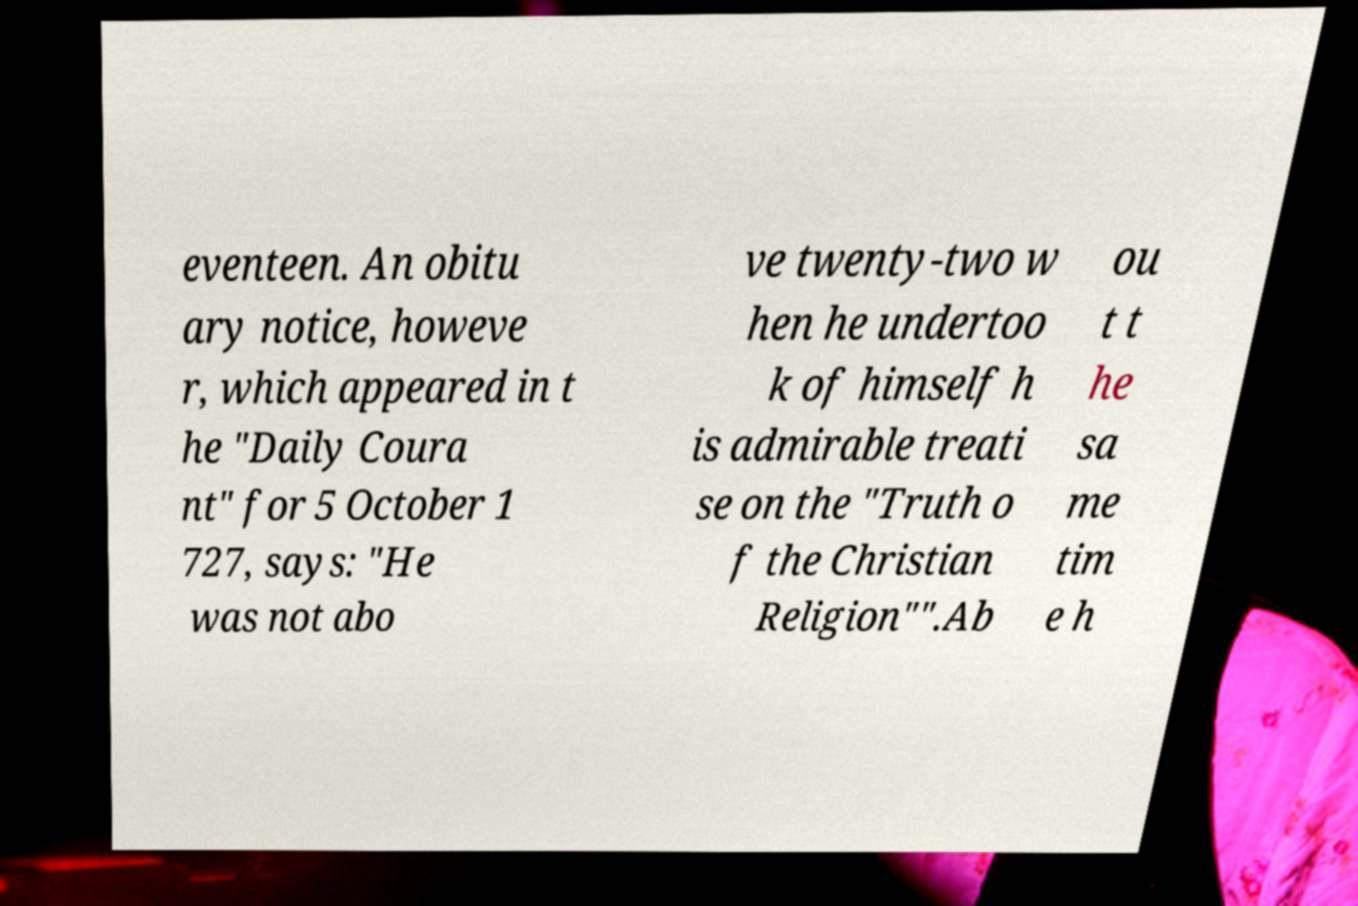For documentation purposes, I need the text within this image transcribed. Could you provide that? eventeen. An obitu ary notice, howeve r, which appeared in t he "Daily Coura nt" for 5 October 1 727, says: "He was not abo ve twenty-two w hen he undertoo k of himself h is admirable treati se on the "Truth o f the Christian Religion"".Ab ou t t he sa me tim e h 